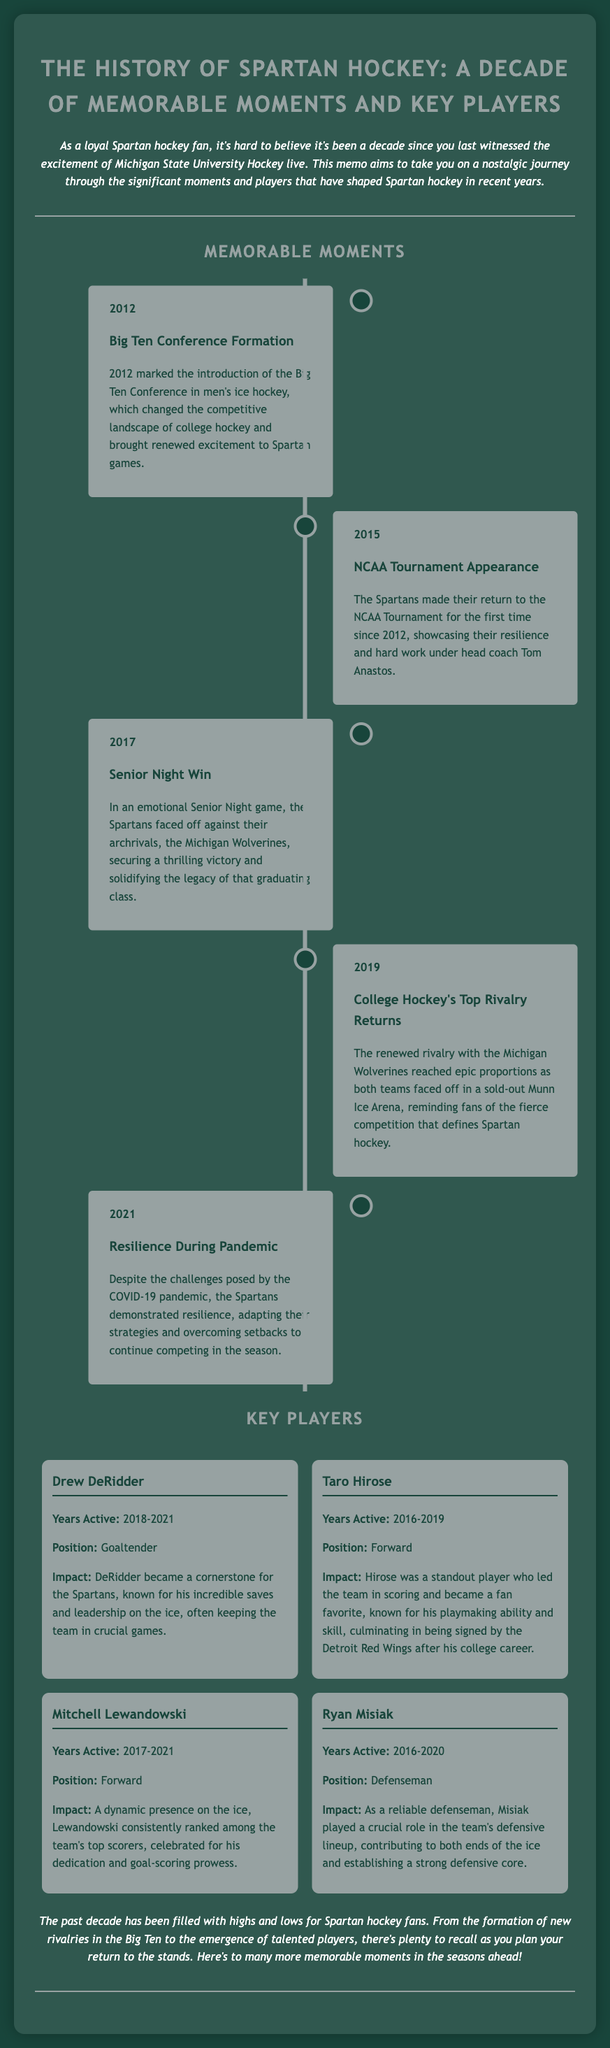What year did the Big Ten Conference form? The document states that the Big Ten Conference was formed in 2012.
Answer: 2012 Who was a standout player leading in scoring? The document mentions Taro Hirose as a standout player who led the team in scoring.
Answer: Taro Hirose What significant event happened in 2015 for Spartan hockey? According to the document, the Spartans made their return to the NCAA Tournament in 2015.
Answer: NCAA Tournament Appearance Which player was active as a goaltender? The document lists Drew DeRidder as the goaltender active from 2018 to 2021.
Answer: Drew DeRidder What notable event occurred during the pandemic in 2021? The document highlights the Spartans' resilience during the COVID-19 pandemic in 2021.
Answer: Resilience During Pandemic How many players are highlighted in the key players section? The document features four key players in the Spartan hockey section.
Answer: Four What rivalry was emphasized in 2019? The document indicates that the rivalry with the Michigan Wolverines was emphasized in 2019.
Answer: Michigan Wolverines What is the overall tone of the introduction? The tone of the introduction is nostalgic, reflecting on a decade of Spartan hockey.
Answer: Nostalgic 